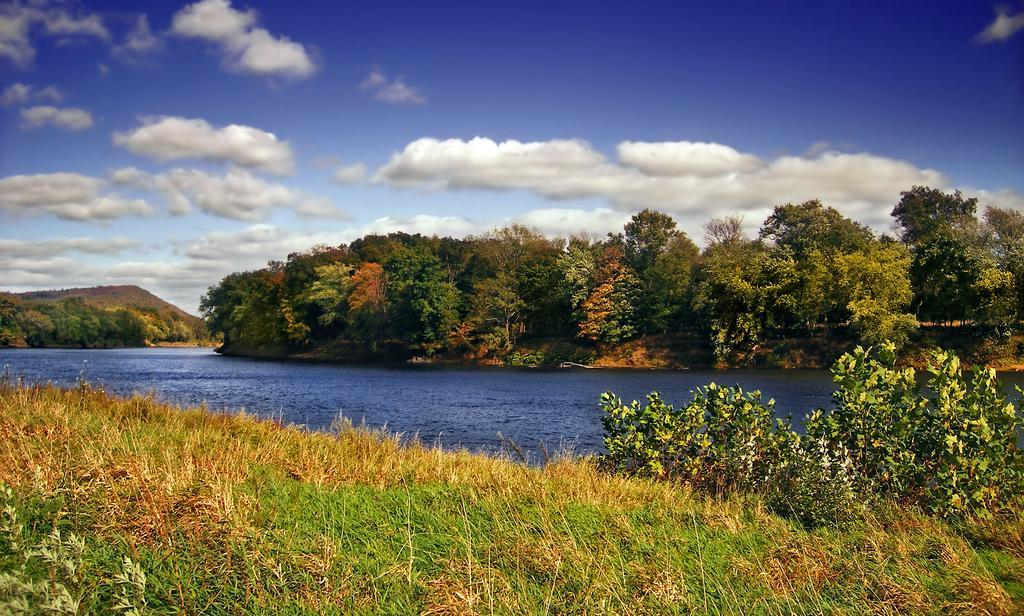Please provide a concise description of this image. In the picture there is water, there is grass, there are trees and plants, there is a hill, there is a cloudy sky. 